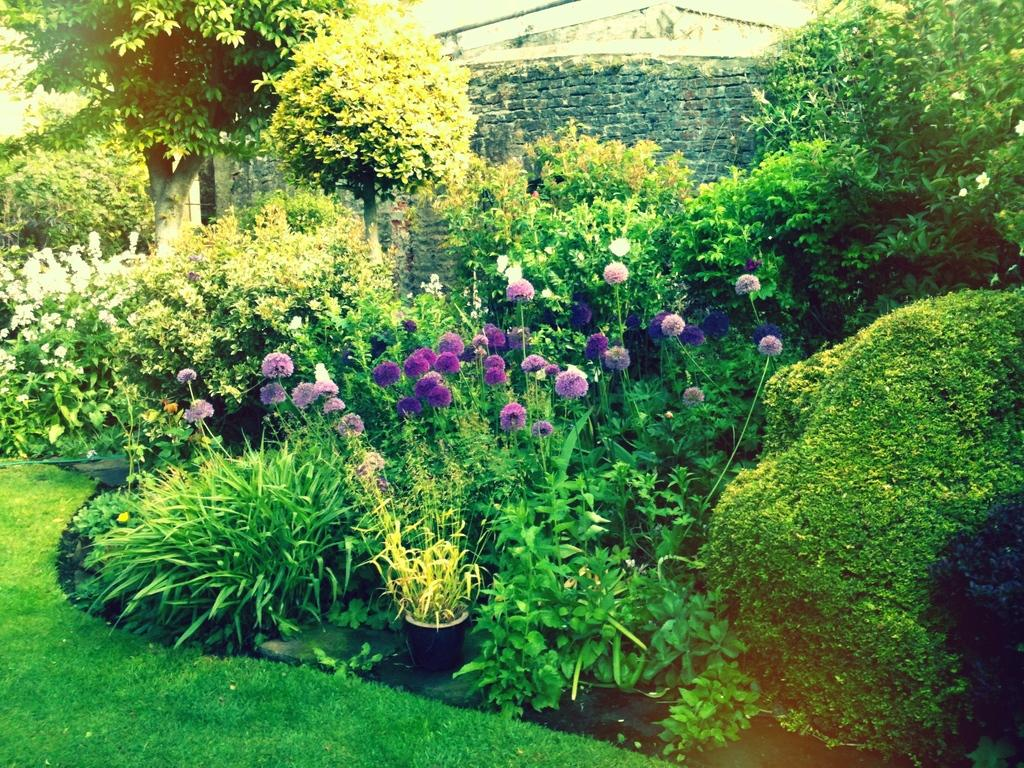What type of plants can be seen in the image? There are flower plants and other plants in the image. What other natural elements are present in the image? There are trees in the image. Where are the plants and trees located? They are on a grassland. What can be seen in the background of the image? There is a wall in the background of the image. Can you tell me how many dogs are playing with the yoke in the image? There are no dogs or yokes present in the image; it features plants, trees, and a wall in the background. 